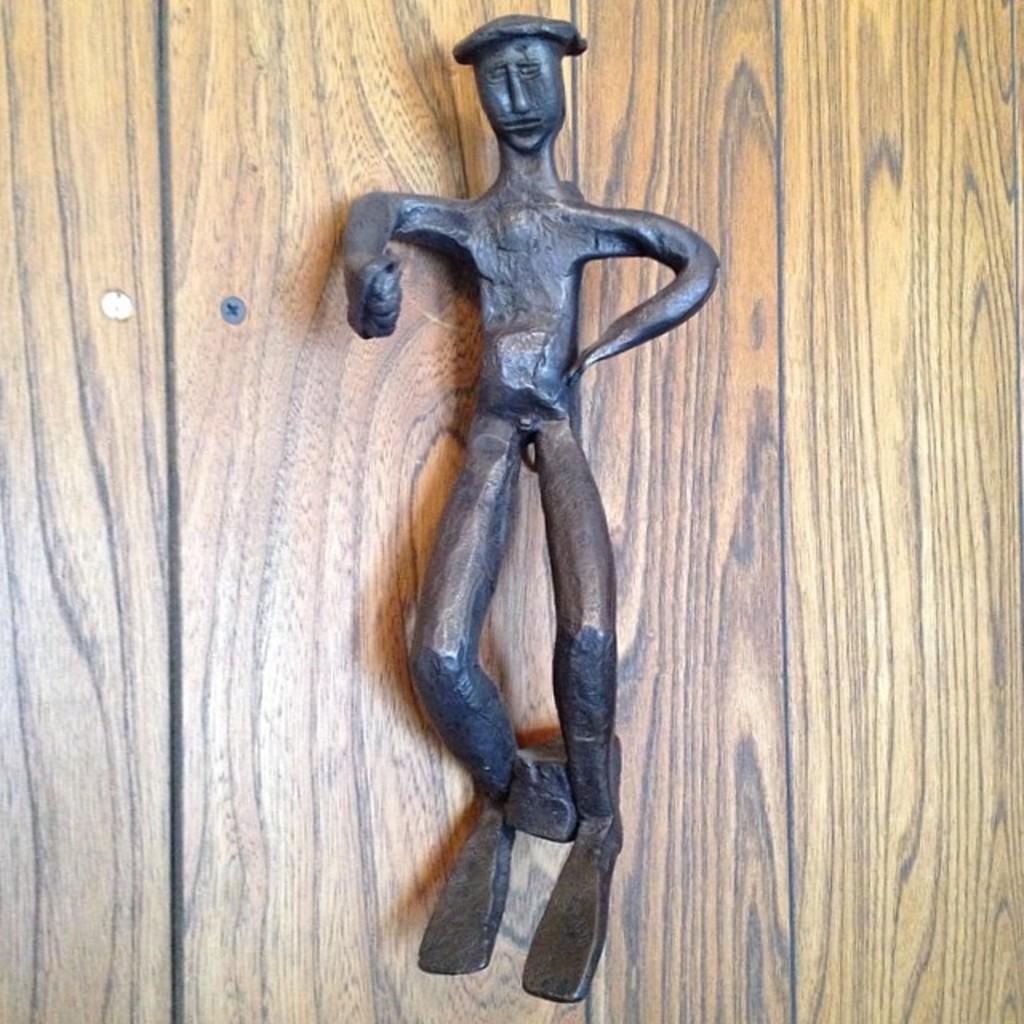How would you summarize this image in a sentence or two? In the center of the picture there is an object made of iron, behind it there is a wooden object. 